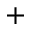Convert formula to latex. <formula><loc_0><loc_0><loc_500><loc_500>+</formula> 